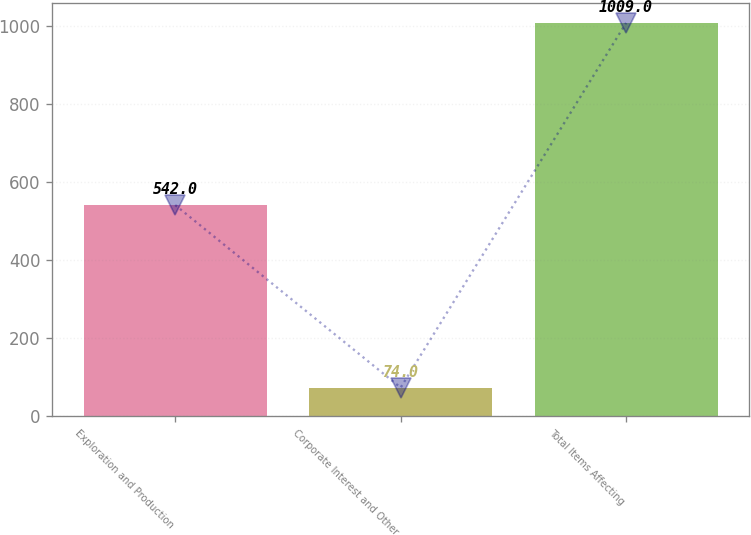Convert chart. <chart><loc_0><loc_0><loc_500><loc_500><bar_chart><fcel>Exploration and Production<fcel>Corporate Interest and Other<fcel>Total Items Affecting<nl><fcel>542<fcel>74<fcel>1009<nl></chart> 